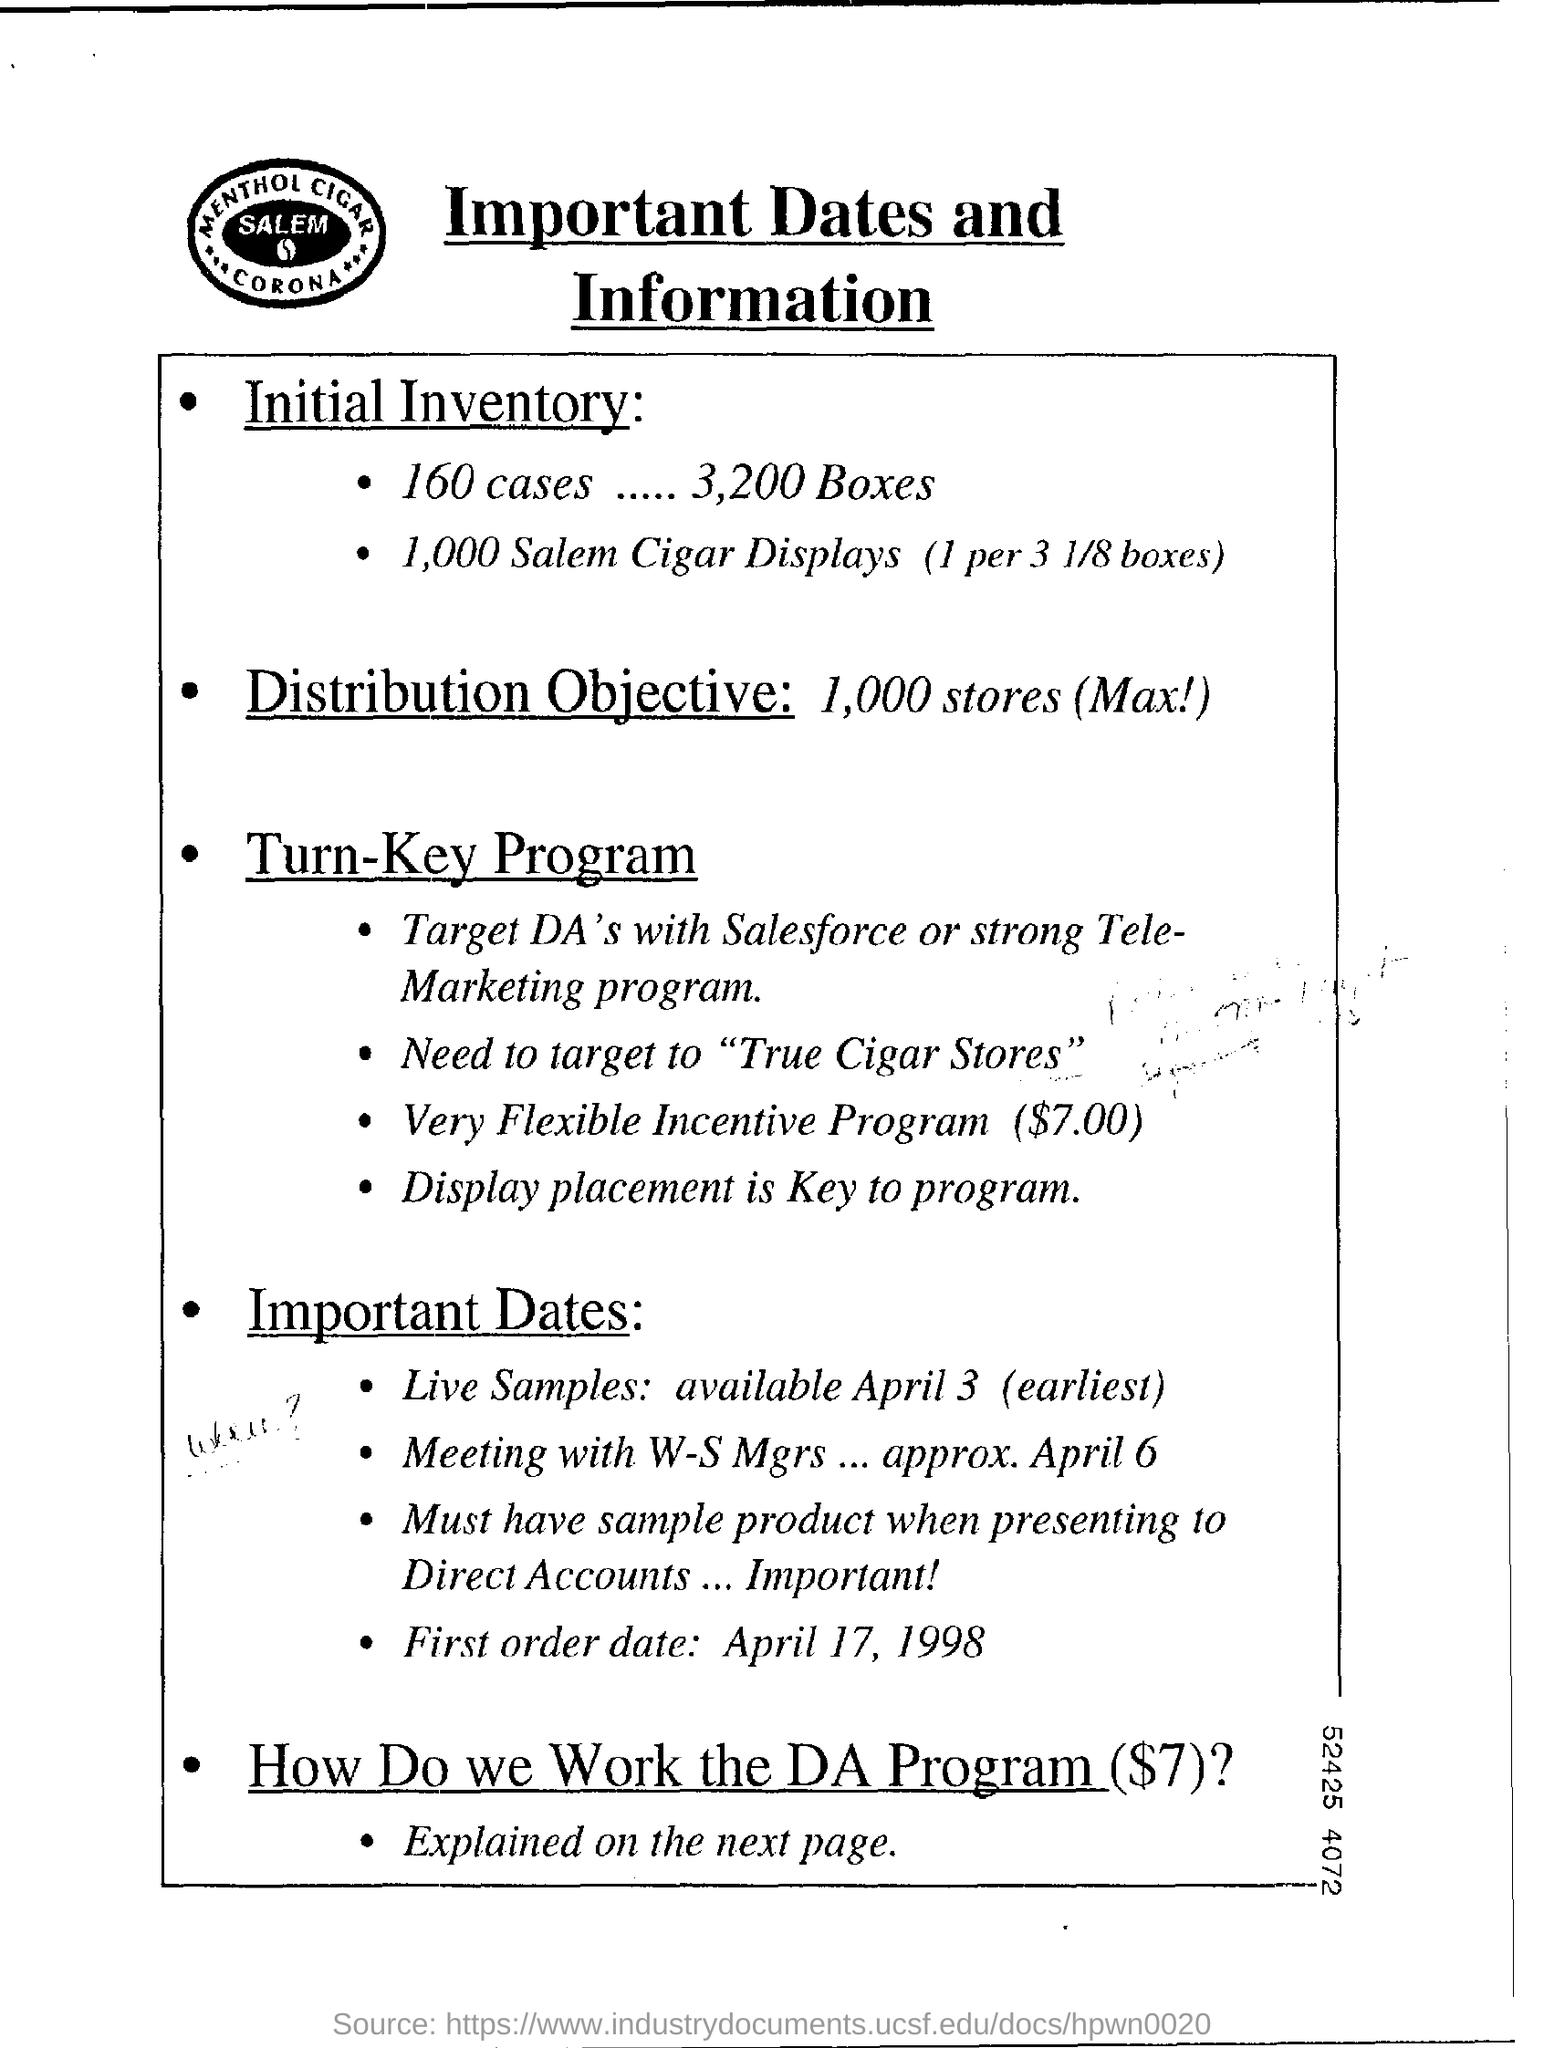Specify some key components in this picture. The heading of the page is "Important dates and information.". 